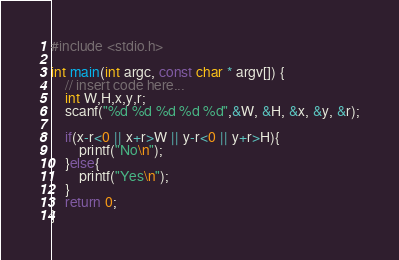<code> <loc_0><loc_0><loc_500><loc_500><_C_>#include <stdio.h>

int main(int argc, const char * argv[]) {
    // insert code here...
    int W,H,x,y,r;
    scanf("%d %d %d %d %d",&W, &H, &x, &y, &r);
    
    if(x-r<0 || x+r>W || y-r<0 || y+r>H){
        printf("No\n");
    }else{
        printf("Yes\n");
    }
    return 0;
}
</code> 